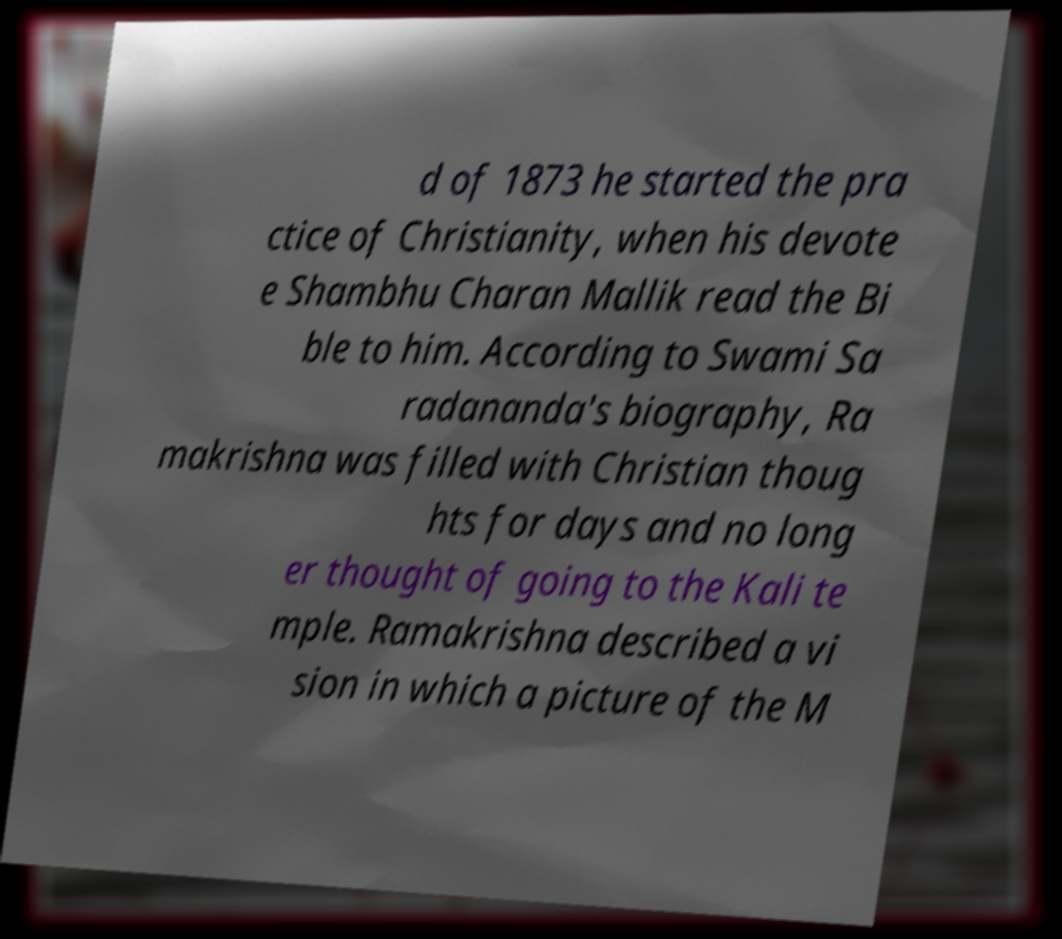There's text embedded in this image that I need extracted. Can you transcribe it verbatim? d of 1873 he started the pra ctice of Christianity, when his devote e Shambhu Charan Mallik read the Bi ble to him. According to Swami Sa radananda's biography, Ra makrishna was filled with Christian thoug hts for days and no long er thought of going to the Kali te mple. Ramakrishna described a vi sion in which a picture of the M 